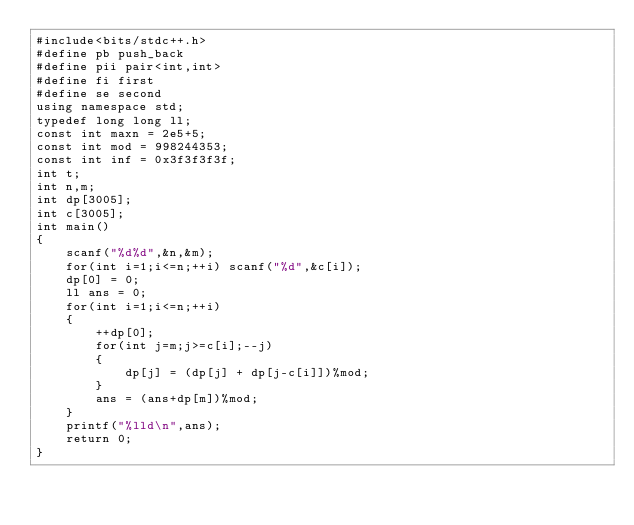Convert code to text. <code><loc_0><loc_0><loc_500><loc_500><_C++_>#include<bits/stdc++.h>
#define pb push_back
#define pii pair<int,int>
#define fi first
#define se second
using namespace std;
typedef long long ll;
const int maxn = 2e5+5;
const int mod = 998244353;
const int inf = 0x3f3f3f3f;
int t;
int n,m;
int dp[3005];
int c[3005];
int main()
{
    scanf("%d%d",&n,&m);
    for(int i=1;i<=n;++i) scanf("%d",&c[i]);
    dp[0] = 0;
    ll ans = 0;
    for(int i=1;i<=n;++i)
    {
        ++dp[0];
        for(int j=m;j>=c[i];--j)
        {
            dp[j] = (dp[j] + dp[j-c[i]])%mod;
        }
        ans = (ans+dp[m])%mod;
    }
    printf("%lld\n",ans);
    return 0;
}
</code> 